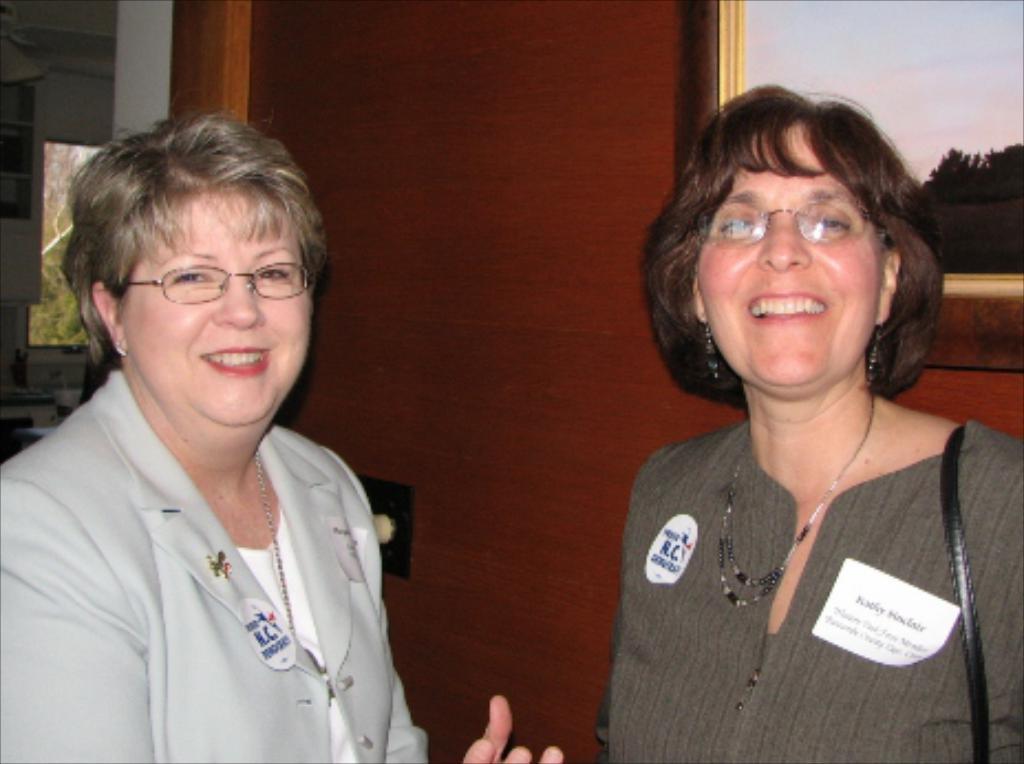Can you describe this image briefly? In this image there are women standing and smiling. In the background there is a door, wall, and there is a window. Outside the window there are trees. 